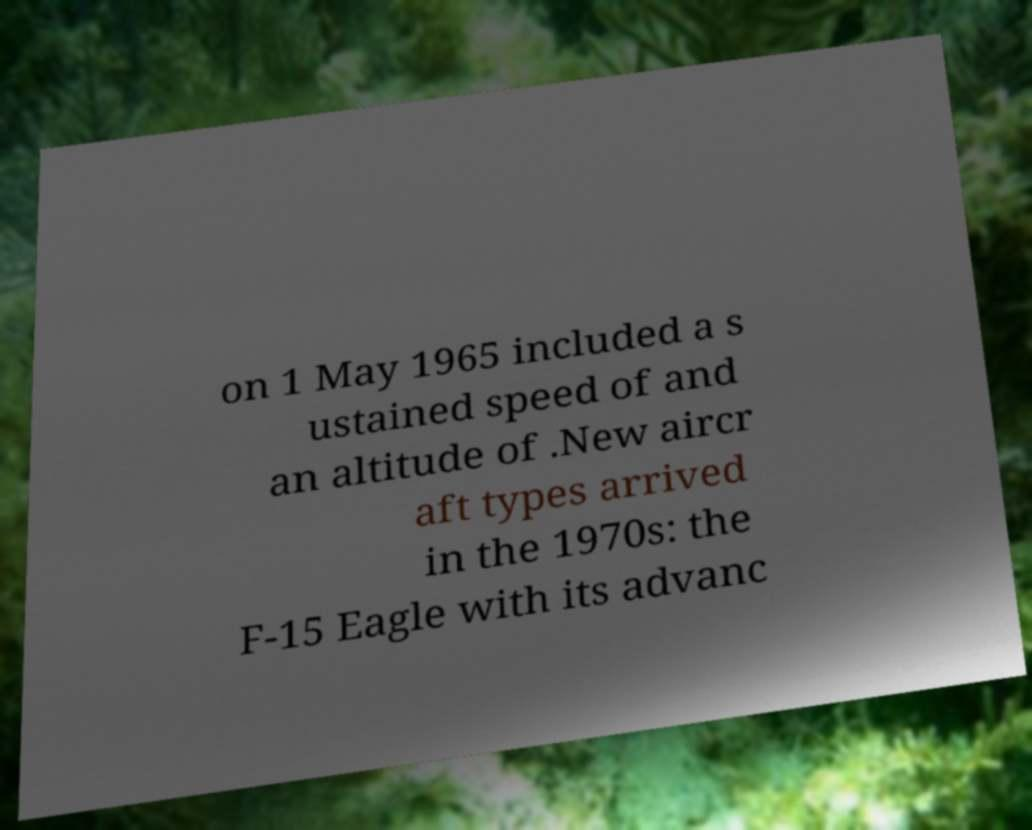Please read and relay the text visible in this image. What does it say? on 1 May 1965 included a s ustained speed of and an altitude of .New aircr aft types arrived in the 1970s: the F-15 Eagle with its advanc 